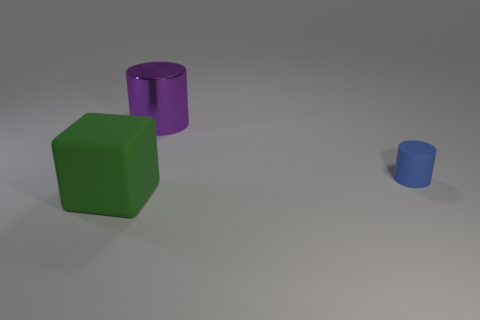What number of other large shiny things have the same shape as the green thing?
Provide a short and direct response. 0. There is a cylinder that is made of the same material as the large green block; what is its size?
Ensure brevity in your answer.  Small. Do the shiny cylinder and the green thing have the same size?
Offer a very short reply. Yes. Is there a large gray metallic block?
Make the answer very short. No. There is a rubber thing that is left of the big object behind the big object in front of the tiny blue object; what size is it?
Offer a very short reply. Large. How many large things are the same material as the green block?
Offer a terse response. 0. How many blue matte cylinders are the same size as the block?
Make the answer very short. 0. What material is the cylinder on the left side of the rubber object that is on the right side of the matte object that is to the left of the big purple object?
Offer a very short reply. Metal. How many things are either large brown blocks or purple shiny cylinders?
Provide a succinct answer. 1. Is there anything else that has the same material as the purple cylinder?
Provide a succinct answer. No. 